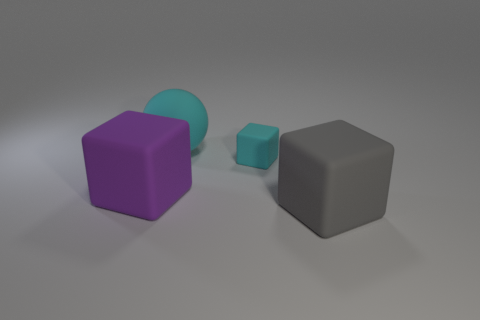There is a large gray thing that is the same material as the purple cube; what shape is it?
Your answer should be very brief. Cube. There is a gray cube that is made of the same material as the big ball; what is its size?
Provide a succinct answer. Large. Is there a thing that has the same color as the small matte block?
Provide a succinct answer. Yes. What number of things are either big objects that are to the left of the tiny thing or large purple objects?
Ensure brevity in your answer.  2. Does the large purple object have the same material as the cyan object that is in front of the large cyan object?
Offer a terse response. Yes. There is a block that is the same color as the matte sphere; what size is it?
Your answer should be compact. Small. Is there a sphere that has the same material as the big purple object?
Provide a short and direct response. Yes. What number of things are either large rubber cubes that are to the left of the large sphere or big matte blocks that are in front of the purple rubber block?
Make the answer very short. 2. Does the small cyan matte object have the same shape as the large rubber object on the left side of the matte sphere?
Make the answer very short. Yes. What number of other objects are the same shape as the large cyan rubber thing?
Ensure brevity in your answer.  0. 